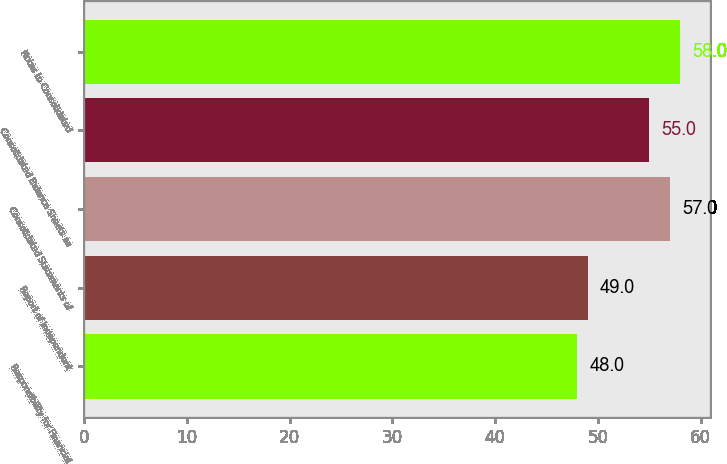<chart> <loc_0><loc_0><loc_500><loc_500><bar_chart><fcel>Responsibility for Financial<fcel>Report of Independent<fcel>Consolidated Statements of<fcel>Consolidated Balance Sheets as<fcel>Notes to Consolidated<nl><fcel>48<fcel>49<fcel>57<fcel>55<fcel>58<nl></chart> 